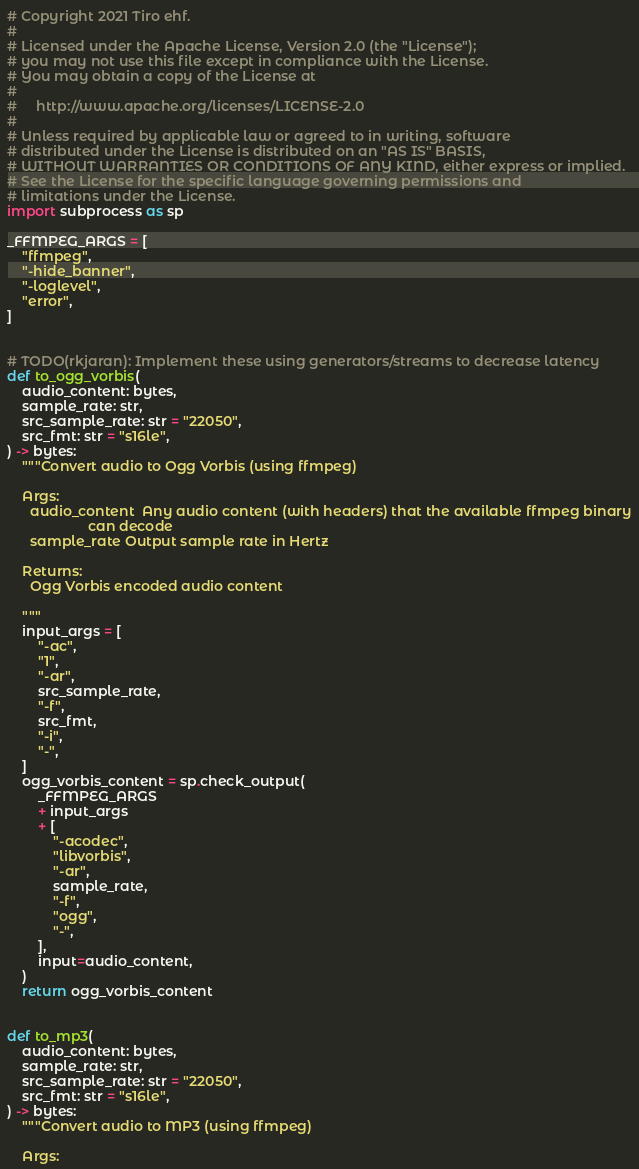<code> <loc_0><loc_0><loc_500><loc_500><_Python_># Copyright 2021 Tiro ehf.
#
# Licensed under the Apache License, Version 2.0 (the "License");
# you may not use this file except in compliance with the License.
# You may obtain a copy of the License at
#
#     http://www.apache.org/licenses/LICENSE-2.0
#
# Unless required by applicable law or agreed to in writing, software
# distributed under the License is distributed on an "AS IS" BASIS,
# WITHOUT WARRANTIES OR CONDITIONS OF ANY KIND, either express or implied.
# See the License for the specific language governing permissions and
# limitations under the License.
import subprocess as sp

_FFMPEG_ARGS = [
    "ffmpeg",
    "-hide_banner",
    "-loglevel",
    "error",
]


# TODO(rkjaran): Implement these using generators/streams to decrease latency
def to_ogg_vorbis(
    audio_content: bytes,
    sample_rate: str,
    src_sample_rate: str = "22050",
    src_fmt: str = "s16le",
) -> bytes:
    """Convert audio to Ogg Vorbis (using ffmpeg)

    Args:
      audio_content  Any audio content (with headers) that the available ffmpeg binary
                     can decode
      sample_rate Output sample rate in Hertz

    Returns:
      Ogg Vorbis encoded audio content

    """
    input_args = [
        "-ac",
        "1",
        "-ar",
        src_sample_rate,
        "-f",
        src_fmt,
        "-i",
        "-",
    ]
    ogg_vorbis_content = sp.check_output(
        _FFMPEG_ARGS
        + input_args
        + [
            "-acodec",
            "libvorbis",
            "-ar",
            sample_rate,
            "-f",
            "ogg",
            "-",
        ],
        input=audio_content,
    )
    return ogg_vorbis_content


def to_mp3(
    audio_content: bytes,
    sample_rate: str,
    src_sample_rate: str = "22050",
    src_fmt: str = "s16le",
) -> bytes:
    """Convert audio to MP3 (using ffmpeg)

    Args:</code> 